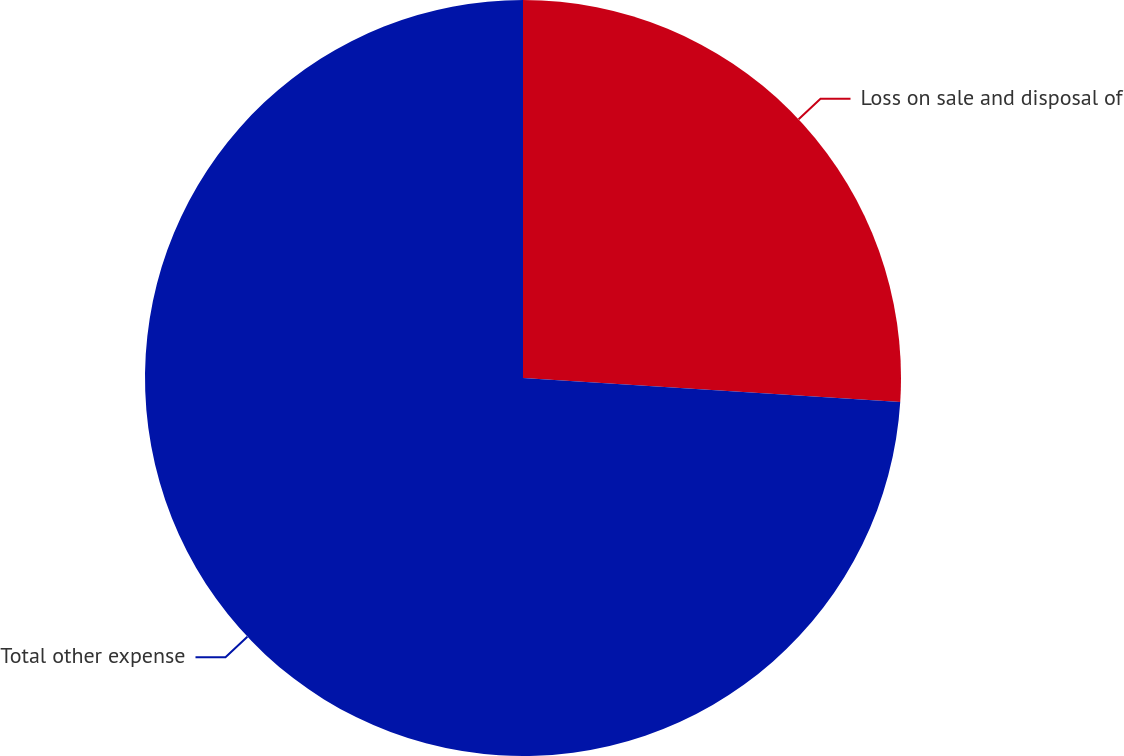<chart> <loc_0><loc_0><loc_500><loc_500><pie_chart><fcel>Loss on sale and disposal of<fcel>Total other expense<nl><fcel>26.01%<fcel>73.99%<nl></chart> 